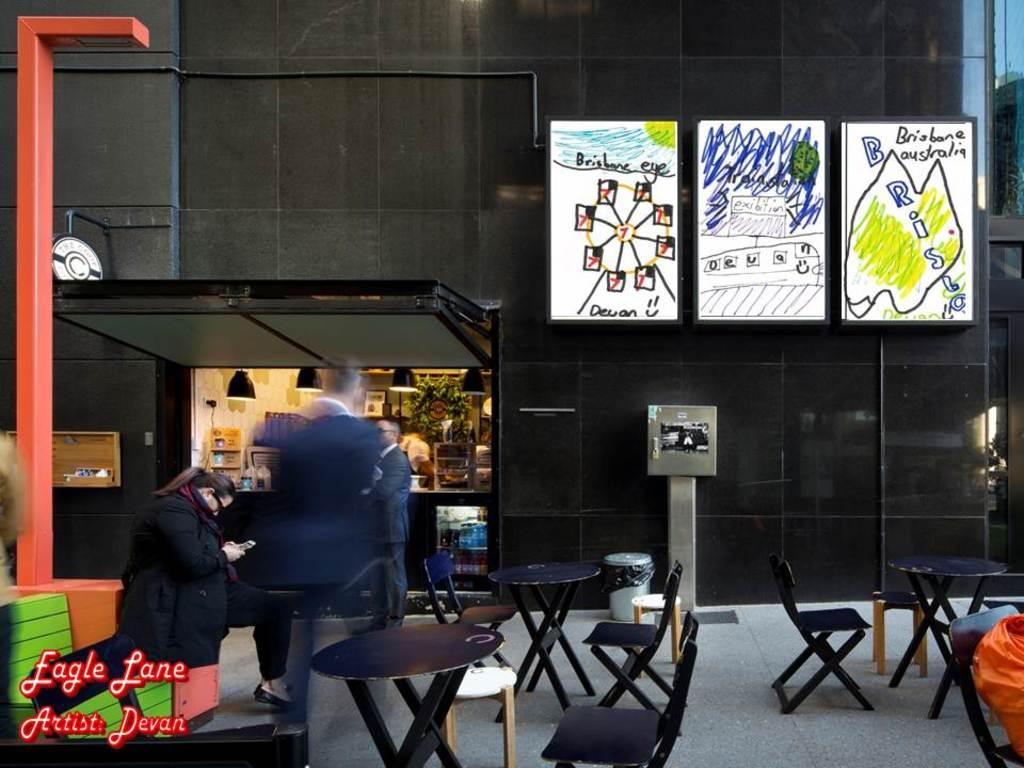What can be seen on the wall in the image? There are posters on the wall in the image. What type of furniture is present in the image? There are chairs and tables in the image. Are there any people in the image? Yes, there are people standing in the image. What kind of place is depicted in the image? The image depicts a store with various things. What type of glove is being used to cause a reaction in the store? There is no glove present in the image, and no reaction is being caused by any object or person. 